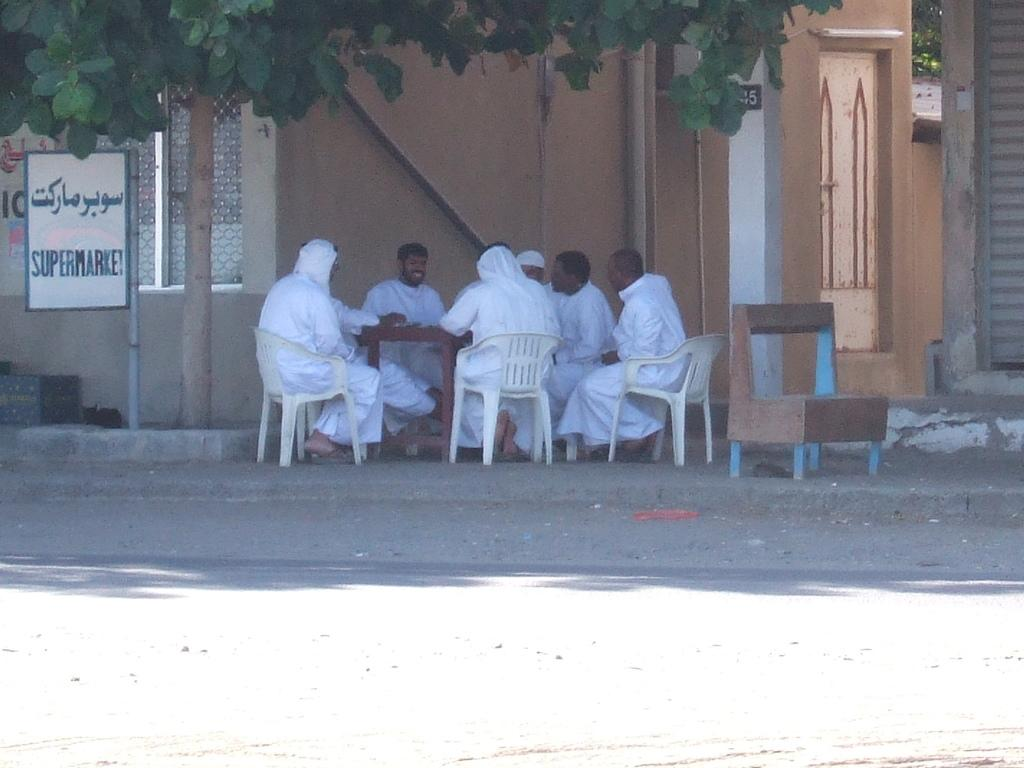What are the people in the image doing? The people in the image are sitting on chairs. What are the people wearing in the image? The people are wearing white dresses. What can be seen on the left side of the image? There is a tree on the left side of the image. Can you tell me how many maps are being pulled by the people in the image? There are no maps present in the image, nor are the people pulling anything. 